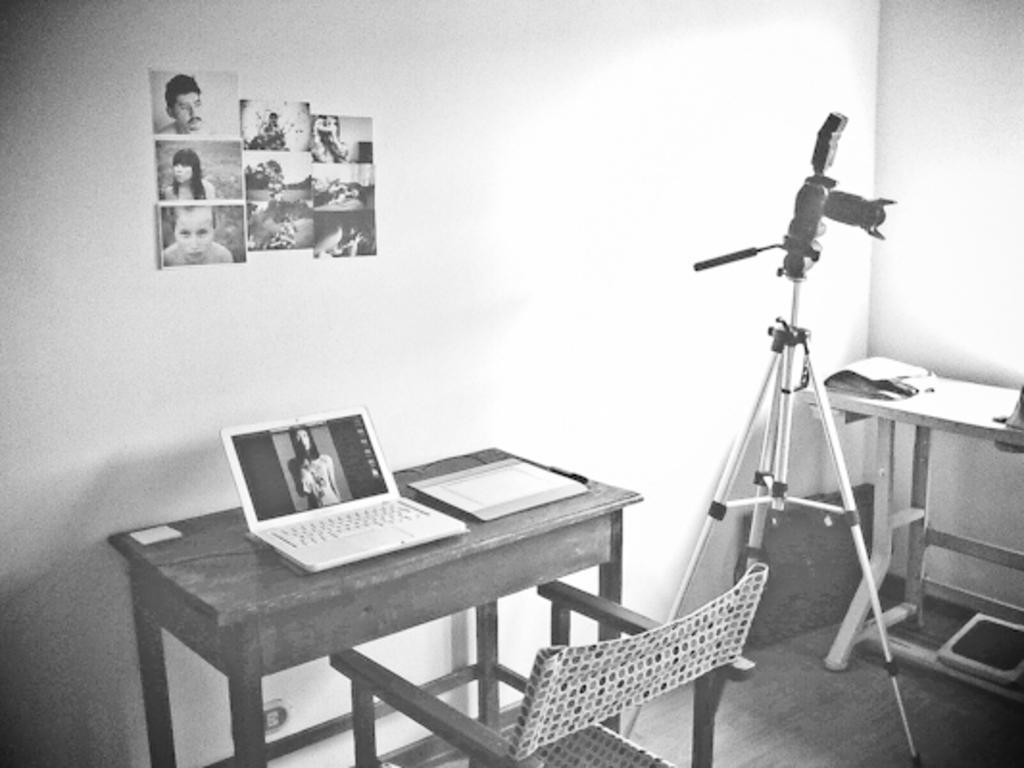Can you describe this image briefly? This is a black and white image. This image is clicked in a room. There are photos posted on the wall. There is a table and a chair, table has laptop and book on it. There is a camera stand on the right side. And there is a table on the right side. 